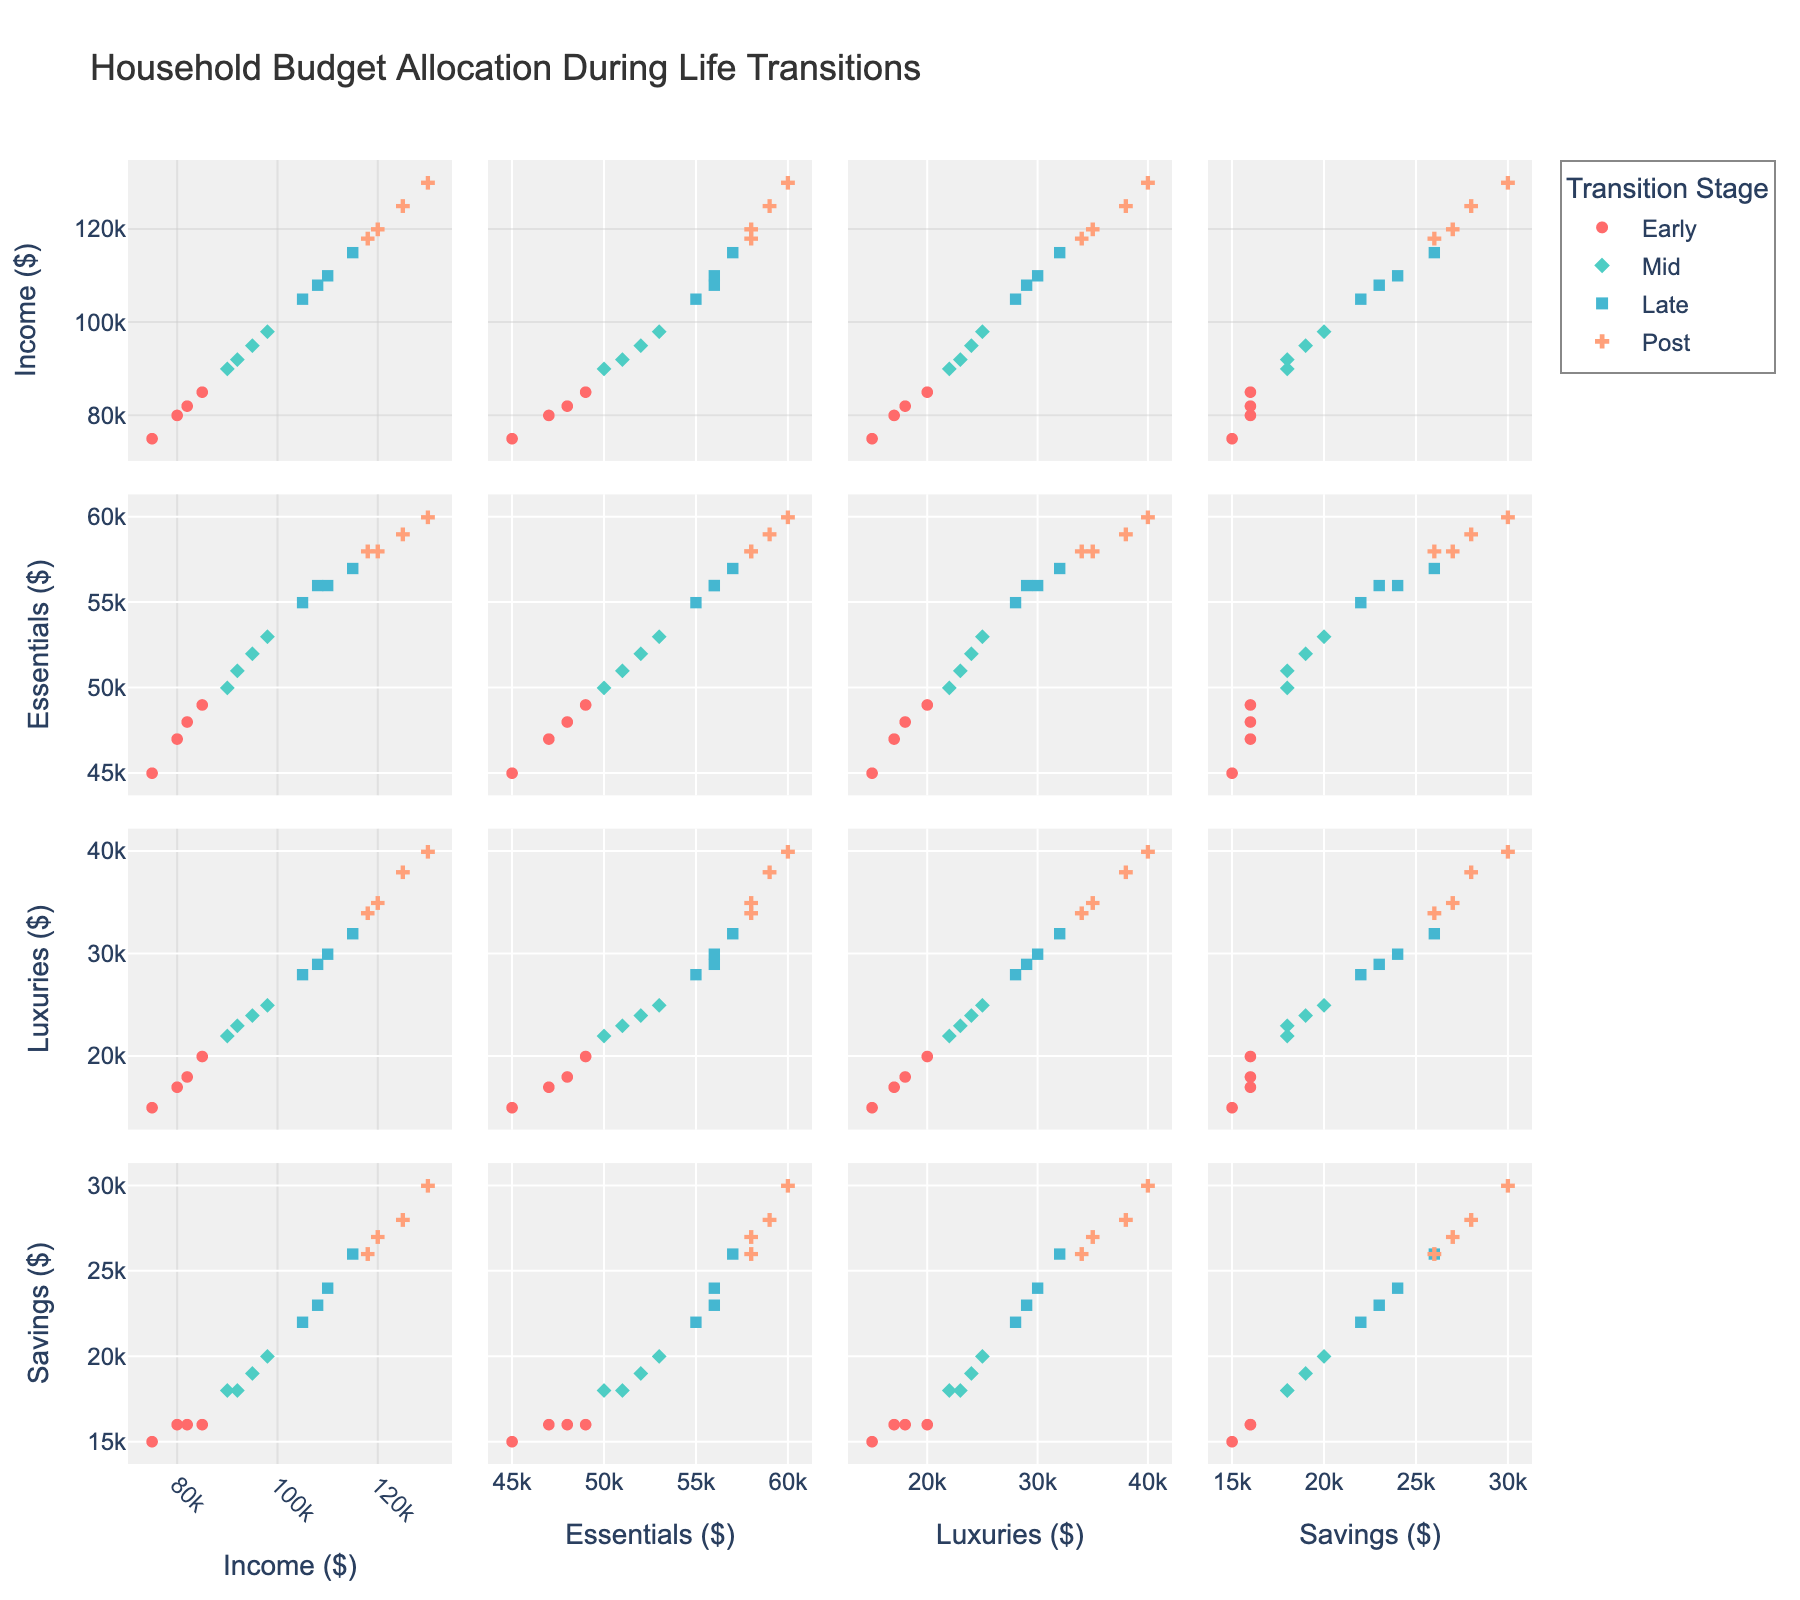What is the overall title of the figure? The overall title can be found at the top center of the figure.
Answer: Renewable Energy Adoption Trends (2010-2022) How many countries are compared in the figure? By counting the number of subplot titles, which each represent a country, the number of countries can be determined.
Answer: 3 Which energy source in Germany saw the highest adoption percentage in 2022? By looking at the last data point for each energy source in the Germany subplot, we can identify the highest one.
Answer: Wind How did solar energy adoption in the USA change from 2010 to 2022? By observing the Solar-USA line, note the y-values in 2010 and in 2022 and calculate the difference. Solar energy adoption increased from 0.1% to 4.7%.
Answer: It increased by 4.6% Which country had the highest percentage of hydro energy in 2010? By comparing the 2010 values of hydro energy in the subplots for the USA, Germany, and China, the highest value can be identified.
Answer: China By how much did wind energy adoption in China increase from 2014 to 2022? Look at the wind energy percentages for China in the years 2014 and 2022, then calculate the difference: 7.2% - 2.8% = 4.4%.
Answer: 4.4% In which year did solar energy adoption in Germany surpass solar energy adoption in the USA? Compare the solar energy lines for Germany and the USA year by year until the Germany line overtakes the USA line. This happened by 2012.
Answer: 2012 What is the trend of hydro energy adoption in Germany from 2010 to 2022? Observing the hydro energy adoption line in the Germany subplot reveals if it increases, decreases, or stays relatively constant. It fluctuated slightly but remained around 3-3.5%.
Answer: Relatively constant Which country exhibits the highest variability in wind energy adoption from 2010 to 2022? By observing the spread and rate of increase of wind energy lines across countries, the country with the most variability can be determined. Germany's wind energy line shows a steep increase, indicating the highest variability.
Answer: Germany In 2018, which energy source contributed the least to the total energy adoption in China? By examining the values for solar, wind, and hydro energy in China in 2018, the smallest value can be identified.
Answer: Hydro 